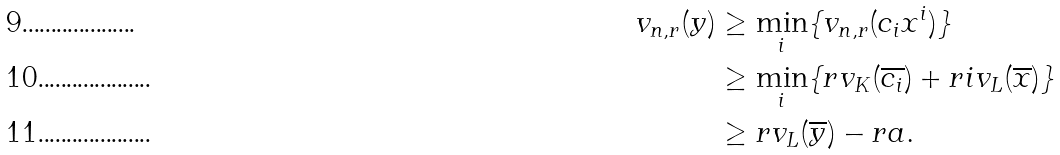<formula> <loc_0><loc_0><loc_500><loc_500>v _ { n , r } ( y ) & \geq \min _ { i } \{ v _ { n , r } ( c _ { i } x ^ { i } ) \} \\ & \geq \min _ { i } \{ r v _ { K } ( \overline { c _ { i } } ) + r i v _ { L } ( \overline { x } ) \} \\ & \geq r v _ { L } ( \overline { y } ) - r a .</formula> 